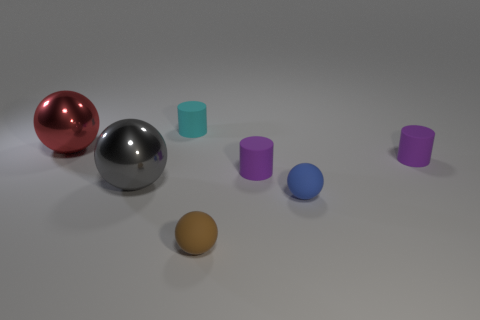Subtract 1 spheres. How many spheres are left? 3 Add 3 metallic spheres. How many objects exist? 10 Subtract all spheres. How many objects are left? 3 Add 5 brown spheres. How many brown spheres are left? 6 Add 4 small rubber cylinders. How many small rubber cylinders exist? 7 Subtract 1 brown spheres. How many objects are left? 6 Subtract all small purple objects. Subtract all tiny matte things. How many objects are left? 0 